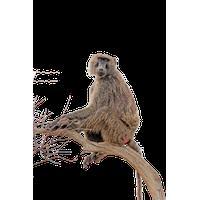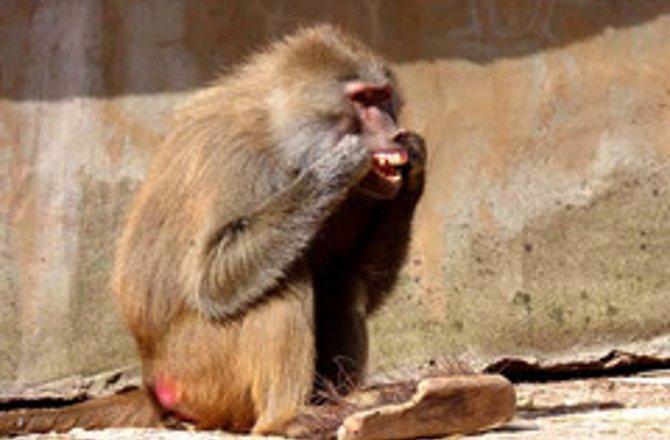The first image is the image on the left, the second image is the image on the right. For the images shown, is this caption "There are exactly three apes." true? Answer yes or no. No. The first image is the image on the left, the second image is the image on the right. Examine the images to the left and right. Is the description "Each image shows two animals interacting, and one image shows a monkey grooming the animal next to it." accurate? Answer yes or no. No. 